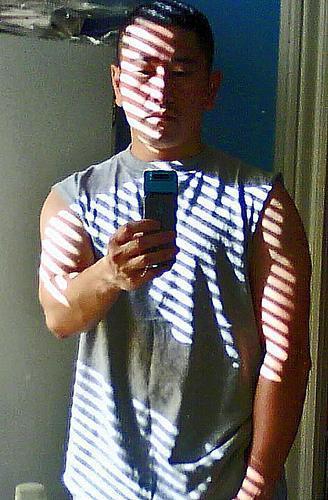How many giraffes are shorter that the lamp post?
Give a very brief answer. 0. 